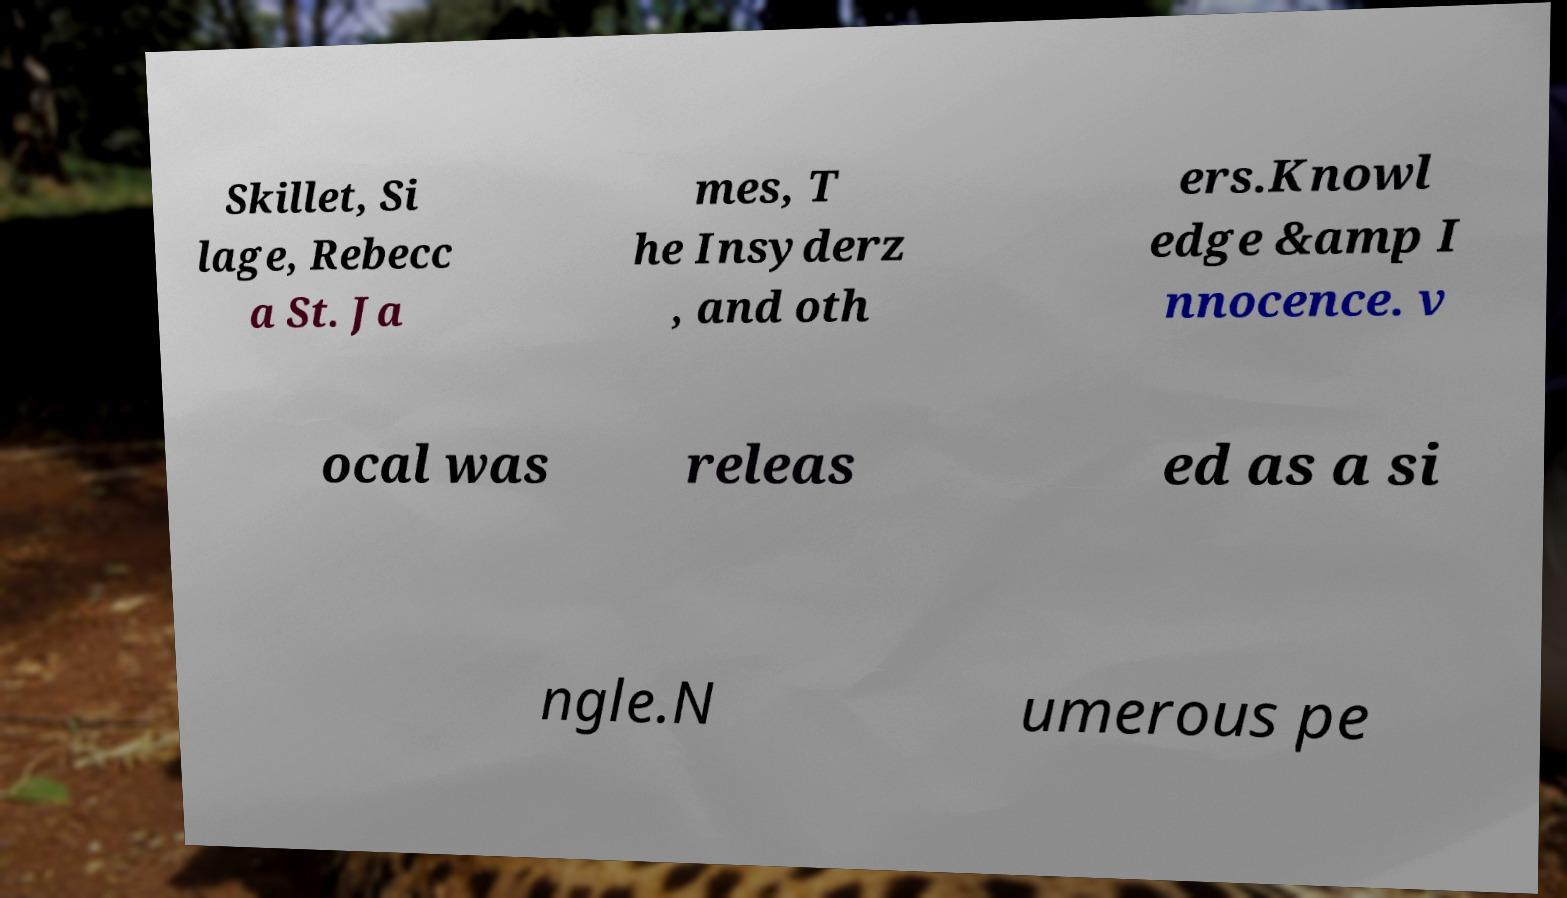There's text embedded in this image that I need extracted. Can you transcribe it verbatim? Skillet, Si lage, Rebecc a St. Ja mes, T he Insyderz , and oth ers.Knowl edge &amp I nnocence. v ocal was releas ed as a si ngle.N umerous pe 